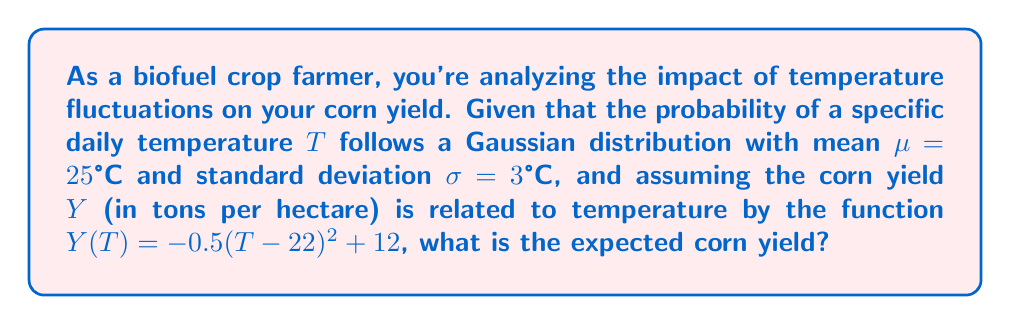Solve this math problem. To solve this problem, we'll use concepts from statistical physics and probability theory:

1) The temperature follows a Gaussian distribution:

   $$P(T) = \frac{1}{\sigma\sqrt{2\pi}} e^{-\frac{(T-\mu)^2}{2\sigma^2}}$$

2) The yield function is:

   $$Y(T) = -0.5(T - 22)^2 + 12$$

3) The expected yield is given by:

   $$E[Y] = \int_{-\infty}^{\infty} Y(T) P(T) dT$$

4) Substituting the functions:

   $$E[Y] = \int_{-\infty}^{\infty} [-0.5(T - 22)^2 + 12] \frac{1}{3\sqrt{2\pi}} e^{-\frac{(T-25)^2}{2(3^2)}} dT$$

5) This integral can be solved using the properties of Gaussian integrals. The key insight is that:

   $$\int_{-\infty}^{\infty} (T - a)^2 e^{-\frac{(T-\mu)^2}{2\sigma^2}} dT = (\sigma^2 + (\mu - a)^2) \sqrt{2\pi\sigma^2}$$

6) Using this, our integral becomes:

   $$E[Y] = -0.5 \cdot \frac{1}{3\sqrt{2\pi}} \cdot (3^2 + (25 - 22)^2) \cdot 3\sqrt{2\pi} + 12$$

7) Simplifying:

   $$E[Y] = -0.5 \cdot (9 + 9) + 12 = -9 + 12 = 3$$

Thus, the expected corn yield is 3 tons per hectare.
Answer: 3 tons per hectare 